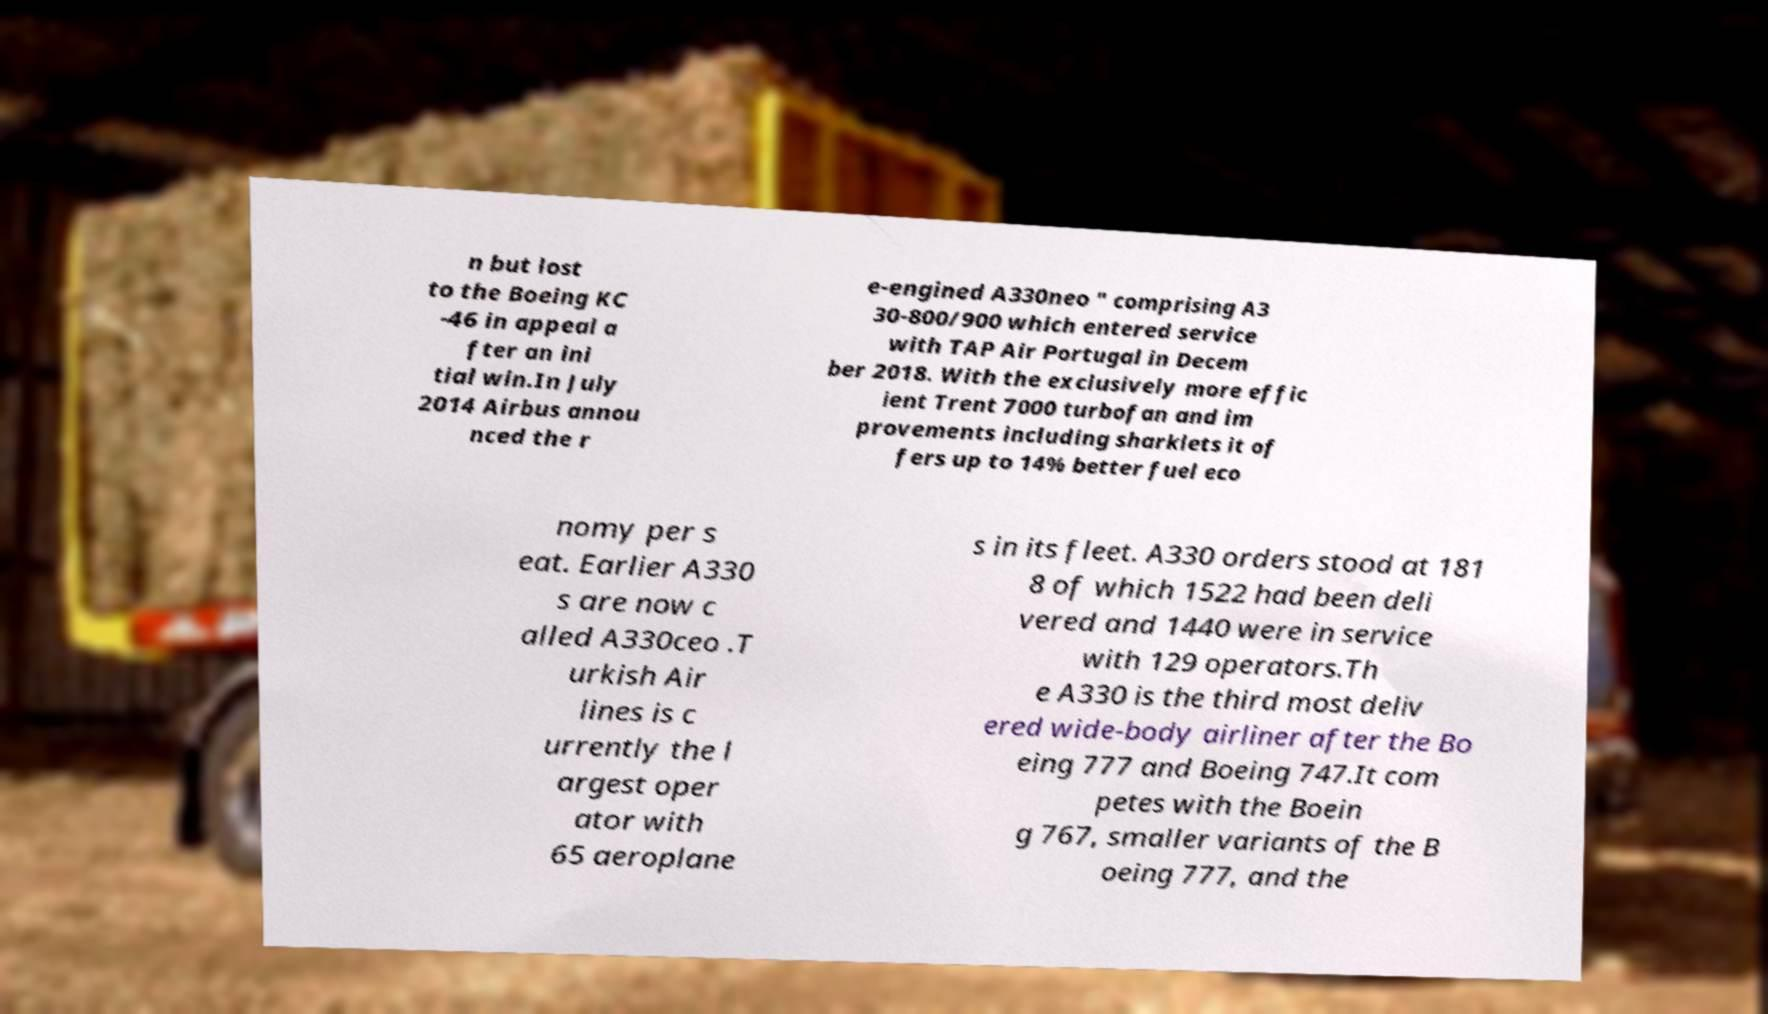What messages or text are displayed in this image? I need them in a readable, typed format. n but lost to the Boeing KC -46 in appeal a fter an ini tial win.In July 2014 Airbus annou nced the r e-engined A330neo " comprising A3 30-800/900 which entered service with TAP Air Portugal in Decem ber 2018. With the exclusively more effic ient Trent 7000 turbofan and im provements including sharklets it of fers up to 14% better fuel eco nomy per s eat. Earlier A330 s are now c alled A330ceo .T urkish Air lines is c urrently the l argest oper ator with 65 aeroplane s in its fleet. A330 orders stood at 181 8 of which 1522 had been deli vered and 1440 were in service with 129 operators.Th e A330 is the third most deliv ered wide-body airliner after the Bo eing 777 and Boeing 747.It com petes with the Boein g 767, smaller variants of the B oeing 777, and the 